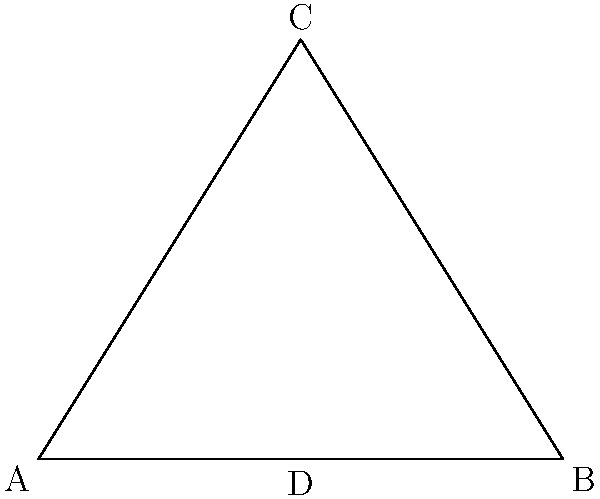In the Great Pyramid of Giza, the base length is 230.4 meters and the height is 146.5 meters. What is the angle of inclination (to the nearest degree) of the pyramid's face to the ground? To find the angle of inclination, we need to use trigonometry. Let's approach this step-by-step:

1) The pyramid can be divided into two right triangles. We'll focus on one of these triangles.

2) In this right triangle:
   - The base (half of the pyramid's base) is 230.4/2 = 115.2 meters
   - The height is 146.5 meters

3) We need to find the angle between the base and the hypotenuse (face of the pyramid). This is the angle of inclination.

4) We can use the tangent function to find this angle:

   $$\tan(\theta) = \frac{\text{opposite}}{\text{adjacent}} = \frac{\text{height}}{\text{half base}}$$

5) Plugging in our values:

   $$\tan(\theta) = \frac{146.5}{115.2}$$

6) To find $\theta$, we need to use the inverse tangent (arctan) function:

   $$\theta = \arctan(\frac{146.5}{115.2})$$

7) Using a calculator:

   $$\theta \approx 51.84^\circ$$

8) Rounding to the nearest degree:

   $$\theta \approx 52^\circ$$

Thus, the angle of inclination of the pyramid's face to the ground is approximately 52°.
Answer: 52° 